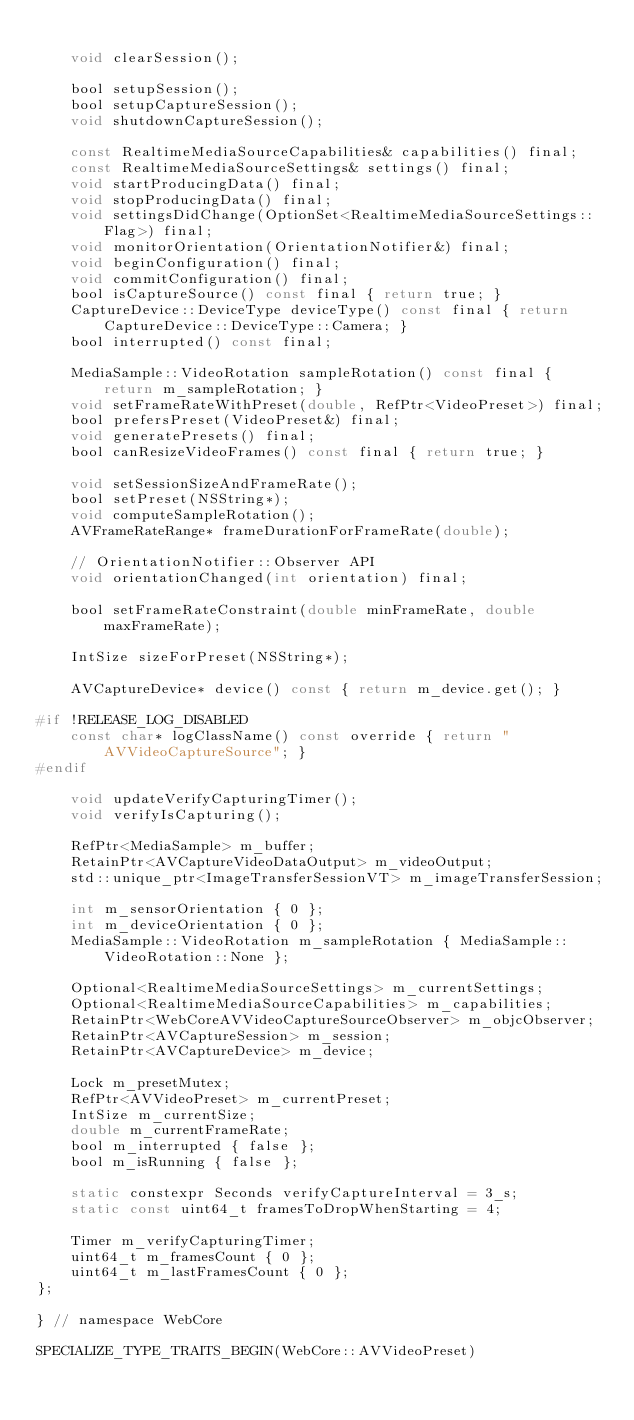Convert code to text. <code><loc_0><loc_0><loc_500><loc_500><_C_>
    void clearSession();

    bool setupSession();
    bool setupCaptureSession();
    void shutdownCaptureSession();

    const RealtimeMediaSourceCapabilities& capabilities() final;
    const RealtimeMediaSourceSettings& settings() final;
    void startProducingData() final;
    void stopProducingData() final;
    void settingsDidChange(OptionSet<RealtimeMediaSourceSettings::Flag>) final;
    void monitorOrientation(OrientationNotifier&) final;
    void beginConfiguration() final;
    void commitConfiguration() final;
    bool isCaptureSource() const final { return true; }
    CaptureDevice::DeviceType deviceType() const final { return CaptureDevice::DeviceType::Camera; }
    bool interrupted() const final;

    MediaSample::VideoRotation sampleRotation() const final { return m_sampleRotation; }
    void setFrameRateWithPreset(double, RefPtr<VideoPreset>) final;
    bool prefersPreset(VideoPreset&) final;
    void generatePresets() final;
    bool canResizeVideoFrames() const final { return true; }

    void setSessionSizeAndFrameRate();
    bool setPreset(NSString*);
    void computeSampleRotation();
    AVFrameRateRange* frameDurationForFrameRate(double);

    // OrientationNotifier::Observer API
    void orientationChanged(int orientation) final;

    bool setFrameRateConstraint(double minFrameRate, double maxFrameRate);

    IntSize sizeForPreset(NSString*);

    AVCaptureDevice* device() const { return m_device.get(); }

#if !RELEASE_LOG_DISABLED
    const char* logClassName() const override { return "AVVideoCaptureSource"; }
#endif

    void updateVerifyCapturingTimer();
    void verifyIsCapturing();

    RefPtr<MediaSample> m_buffer;
    RetainPtr<AVCaptureVideoDataOutput> m_videoOutput;
    std::unique_ptr<ImageTransferSessionVT> m_imageTransferSession;

    int m_sensorOrientation { 0 };
    int m_deviceOrientation { 0 };
    MediaSample::VideoRotation m_sampleRotation { MediaSample::VideoRotation::None };

    Optional<RealtimeMediaSourceSettings> m_currentSettings;
    Optional<RealtimeMediaSourceCapabilities> m_capabilities;
    RetainPtr<WebCoreAVVideoCaptureSourceObserver> m_objcObserver;
    RetainPtr<AVCaptureSession> m_session;
    RetainPtr<AVCaptureDevice> m_device;

    Lock m_presetMutex;
    RefPtr<AVVideoPreset> m_currentPreset;
    IntSize m_currentSize;
    double m_currentFrameRate;
    bool m_interrupted { false };
    bool m_isRunning { false };

    static constexpr Seconds verifyCaptureInterval = 3_s;
    static const uint64_t framesToDropWhenStarting = 4;

    Timer m_verifyCapturingTimer;
    uint64_t m_framesCount { 0 };
    uint64_t m_lastFramesCount { 0 };
};

} // namespace WebCore

SPECIALIZE_TYPE_TRAITS_BEGIN(WebCore::AVVideoPreset)</code> 